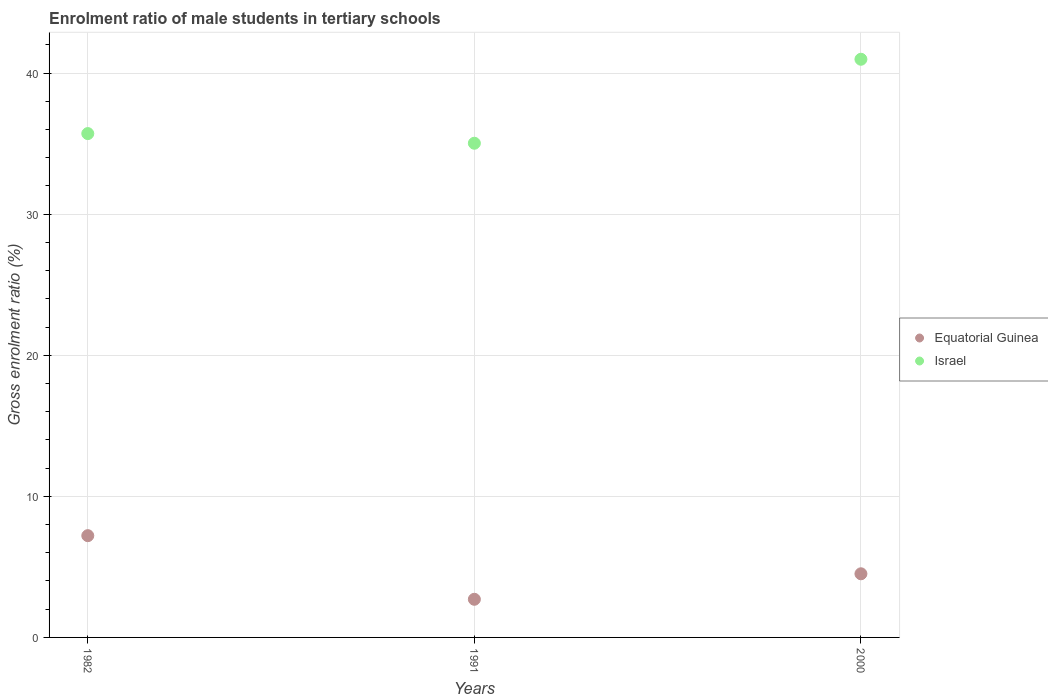Is the number of dotlines equal to the number of legend labels?
Offer a very short reply. Yes. What is the enrolment ratio of male students in tertiary schools in Israel in 2000?
Make the answer very short. 40.98. Across all years, what is the maximum enrolment ratio of male students in tertiary schools in Israel?
Your answer should be very brief. 40.98. Across all years, what is the minimum enrolment ratio of male students in tertiary schools in Equatorial Guinea?
Give a very brief answer. 2.7. In which year was the enrolment ratio of male students in tertiary schools in Equatorial Guinea minimum?
Offer a very short reply. 1991. What is the total enrolment ratio of male students in tertiary schools in Israel in the graph?
Ensure brevity in your answer.  111.72. What is the difference between the enrolment ratio of male students in tertiary schools in Equatorial Guinea in 1982 and that in 1991?
Your answer should be compact. 4.51. What is the difference between the enrolment ratio of male students in tertiary schools in Equatorial Guinea in 1991 and the enrolment ratio of male students in tertiary schools in Israel in 1982?
Provide a succinct answer. -33.01. What is the average enrolment ratio of male students in tertiary schools in Israel per year?
Offer a terse response. 37.24. In the year 1991, what is the difference between the enrolment ratio of male students in tertiary schools in Israel and enrolment ratio of male students in tertiary schools in Equatorial Guinea?
Make the answer very short. 32.32. What is the ratio of the enrolment ratio of male students in tertiary schools in Israel in 1982 to that in 1991?
Offer a very short reply. 1.02. Is the enrolment ratio of male students in tertiary schools in Equatorial Guinea in 1991 less than that in 2000?
Keep it short and to the point. Yes. What is the difference between the highest and the second highest enrolment ratio of male students in tertiary schools in Equatorial Guinea?
Your answer should be very brief. 2.7. What is the difference between the highest and the lowest enrolment ratio of male students in tertiary schools in Equatorial Guinea?
Your answer should be compact. 4.51. Does the enrolment ratio of male students in tertiary schools in Equatorial Guinea monotonically increase over the years?
Offer a terse response. No. Are the values on the major ticks of Y-axis written in scientific E-notation?
Ensure brevity in your answer.  No. How many legend labels are there?
Your answer should be compact. 2. What is the title of the graph?
Offer a very short reply. Enrolment ratio of male students in tertiary schools. Does "United Arab Emirates" appear as one of the legend labels in the graph?
Your response must be concise. No. What is the label or title of the X-axis?
Keep it short and to the point. Years. What is the Gross enrolment ratio (%) of Equatorial Guinea in 1982?
Make the answer very short. 7.21. What is the Gross enrolment ratio (%) of Israel in 1982?
Your response must be concise. 35.71. What is the Gross enrolment ratio (%) in Equatorial Guinea in 1991?
Give a very brief answer. 2.7. What is the Gross enrolment ratio (%) of Israel in 1991?
Keep it short and to the point. 35.03. What is the Gross enrolment ratio (%) in Equatorial Guinea in 2000?
Offer a terse response. 4.51. What is the Gross enrolment ratio (%) of Israel in 2000?
Make the answer very short. 40.98. Across all years, what is the maximum Gross enrolment ratio (%) in Equatorial Guinea?
Provide a short and direct response. 7.21. Across all years, what is the maximum Gross enrolment ratio (%) of Israel?
Keep it short and to the point. 40.98. Across all years, what is the minimum Gross enrolment ratio (%) in Equatorial Guinea?
Provide a succinct answer. 2.7. Across all years, what is the minimum Gross enrolment ratio (%) of Israel?
Keep it short and to the point. 35.03. What is the total Gross enrolment ratio (%) of Equatorial Guinea in the graph?
Give a very brief answer. 14.43. What is the total Gross enrolment ratio (%) of Israel in the graph?
Ensure brevity in your answer.  111.72. What is the difference between the Gross enrolment ratio (%) of Equatorial Guinea in 1982 and that in 1991?
Provide a succinct answer. 4.51. What is the difference between the Gross enrolment ratio (%) of Israel in 1982 and that in 1991?
Provide a short and direct response. 0.68. What is the difference between the Gross enrolment ratio (%) of Equatorial Guinea in 1982 and that in 2000?
Offer a terse response. 2.7. What is the difference between the Gross enrolment ratio (%) of Israel in 1982 and that in 2000?
Give a very brief answer. -5.27. What is the difference between the Gross enrolment ratio (%) in Equatorial Guinea in 1991 and that in 2000?
Your answer should be compact. -1.81. What is the difference between the Gross enrolment ratio (%) in Israel in 1991 and that in 2000?
Provide a succinct answer. -5.95. What is the difference between the Gross enrolment ratio (%) in Equatorial Guinea in 1982 and the Gross enrolment ratio (%) in Israel in 1991?
Your answer should be very brief. -27.82. What is the difference between the Gross enrolment ratio (%) in Equatorial Guinea in 1982 and the Gross enrolment ratio (%) in Israel in 2000?
Provide a succinct answer. -33.77. What is the difference between the Gross enrolment ratio (%) of Equatorial Guinea in 1991 and the Gross enrolment ratio (%) of Israel in 2000?
Your answer should be very brief. -38.28. What is the average Gross enrolment ratio (%) of Equatorial Guinea per year?
Your answer should be compact. 4.81. What is the average Gross enrolment ratio (%) of Israel per year?
Make the answer very short. 37.24. In the year 1982, what is the difference between the Gross enrolment ratio (%) of Equatorial Guinea and Gross enrolment ratio (%) of Israel?
Your response must be concise. -28.5. In the year 1991, what is the difference between the Gross enrolment ratio (%) of Equatorial Guinea and Gross enrolment ratio (%) of Israel?
Your response must be concise. -32.32. In the year 2000, what is the difference between the Gross enrolment ratio (%) of Equatorial Guinea and Gross enrolment ratio (%) of Israel?
Make the answer very short. -36.47. What is the ratio of the Gross enrolment ratio (%) in Equatorial Guinea in 1982 to that in 1991?
Your response must be concise. 2.67. What is the ratio of the Gross enrolment ratio (%) of Israel in 1982 to that in 1991?
Your answer should be very brief. 1.02. What is the ratio of the Gross enrolment ratio (%) in Equatorial Guinea in 1982 to that in 2000?
Provide a succinct answer. 1.6. What is the ratio of the Gross enrolment ratio (%) in Israel in 1982 to that in 2000?
Your response must be concise. 0.87. What is the ratio of the Gross enrolment ratio (%) of Equatorial Guinea in 1991 to that in 2000?
Provide a succinct answer. 0.6. What is the ratio of the Gross enrolment ratio (%) in Israel in 1991 to that in 2000?
Keep it short and to the point. 0.85. What is the difference between the highest and the second highest Gross enrolment ratio (%) in Equatorial Guinea?
Ensure brevity in your answer.  2.7. What is the difference between the highest and the second highest Gross enrolment ratio (%) in Israel?
Ensure brevity in your answer.  5.27. What is the difference between the highest and the lowest Gross enrolment ratio (%) in Equatorial Guinea?
Provide a succinct answer. 4.51. What is the difference between the highest and the lowest Gross enrolment ratio (%) of Israel?
Your response must be concise. 5.95. 